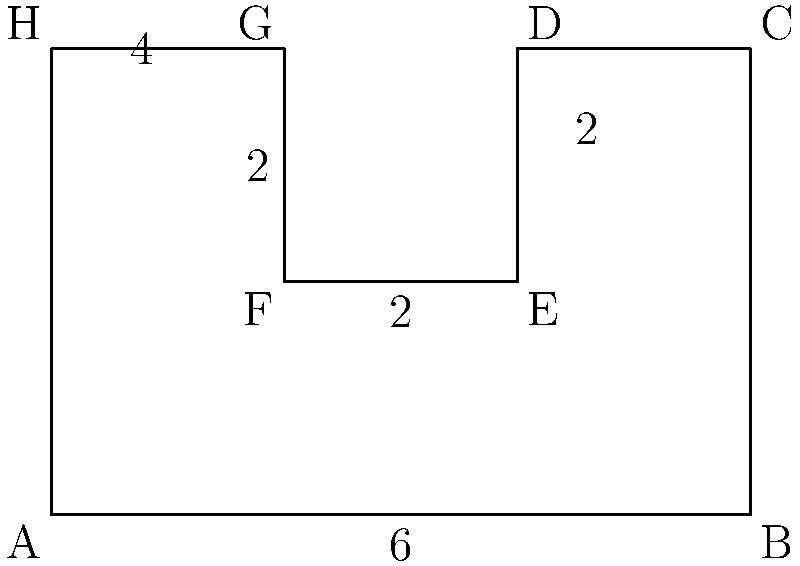As a music producer, you're designing an album cover where each track is represented by a section of a polygon. The cover design forms an irregular octagon as shown in the figure. If each unit in the grid represents 1 inch, what is the total area of the album cover in square inches? To calculate the area of this irregular octagon, we can divide it into simpler shapes and sum their areas:

1. First, divide the octagon into a rectangle and two smaller rectangles:
   - Main rectangle: 6 inches × 4 inches
   - Left rectangle: 2 inches × 2 inches
   - Right rectangle: 2 inches × 2 inches

2. Calculate the areas:
   - Area of main rectangle: $A_1 = 6 \times 4 = 24$ sq inches
   - Area of left rectangle: $A_2 = 2 \times 2 = 4$ sq inches
   - Area of right rectangle: $A_3 = 2 \times 2 = 4$ sq inches

3. Sum up all areas:
   $A_{total} = A_1 + A_2 + A_3 = 24 + 4 + 4 = 32$ sq inches

Therefore, the total area of the album cover is 32 square inches.
Answer: 32 sq inches 